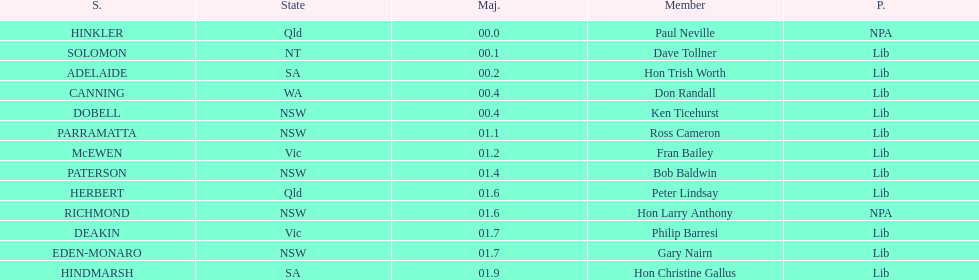How many states were represented in the seats? 6. 